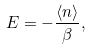<formula> <loc_0><loc_0><loc_500><loc_500>E = - \frac { \langle n \rangle } { \beta } ,</formula> 